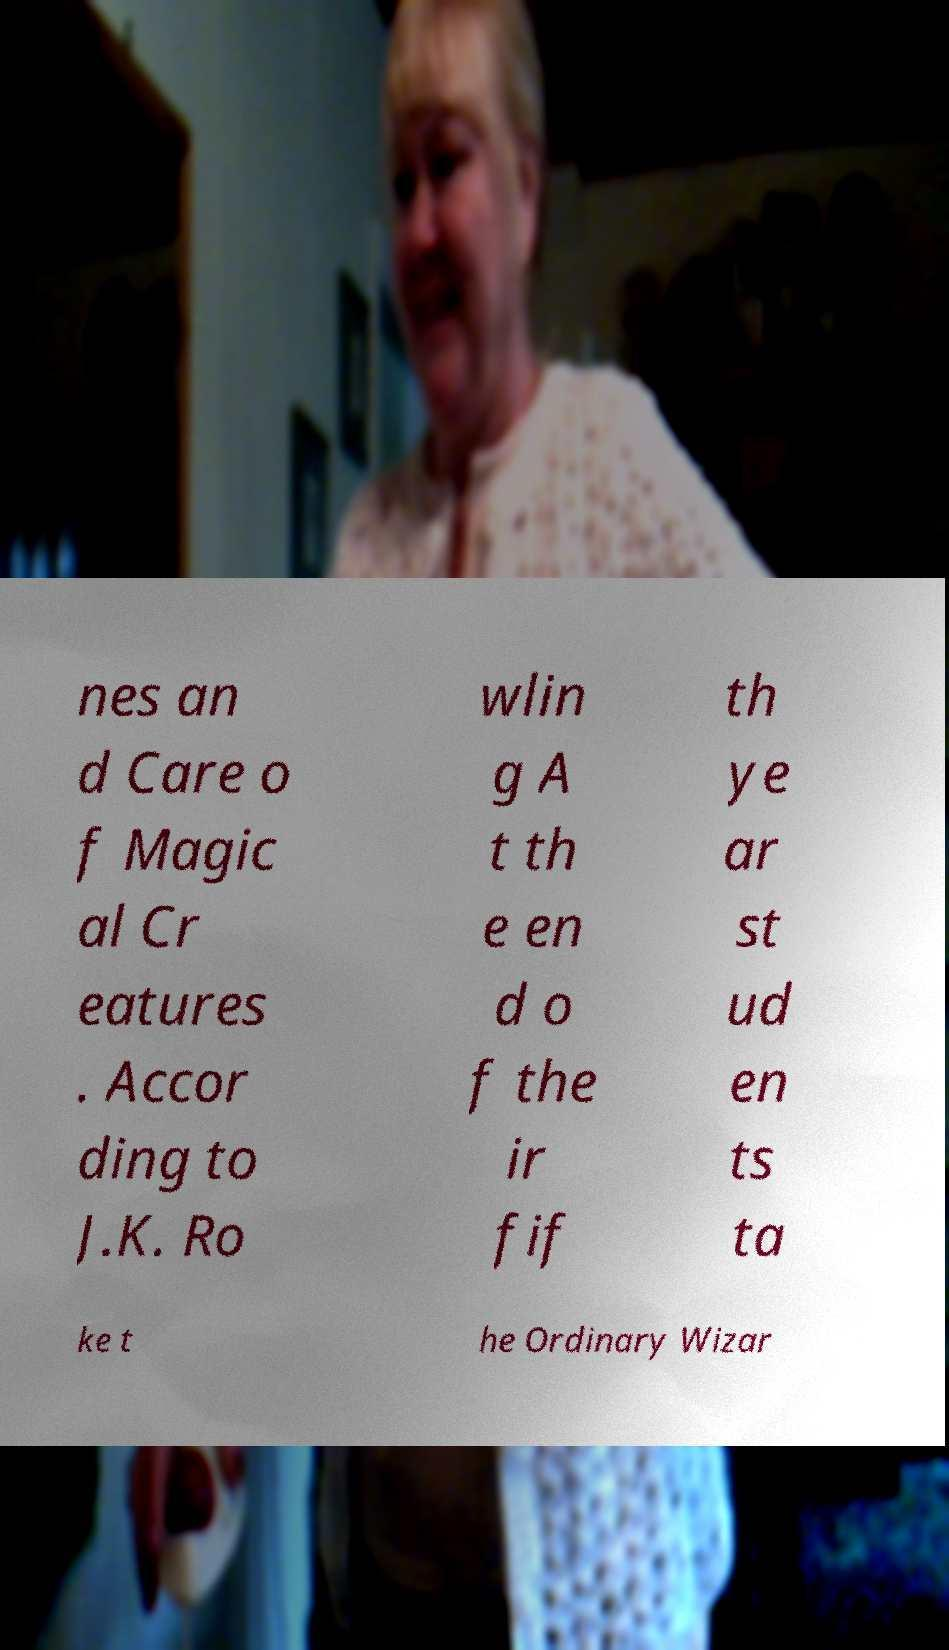For documentation purposes, I need the text within this image transcribed. Could you provide that? nes an d Care o f Magic al Cr eatures . Accor ding to J.K. Ro wlin g A t th e en d o f the ir fif th ye ar st ud en ts ta ke t he Ordinary Wizar 